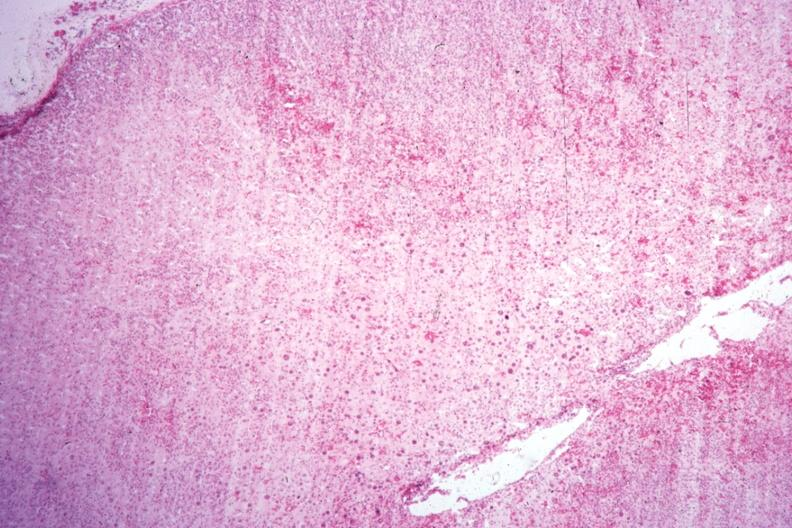s parathyroid present?
Answer the question using a single word or phrase. No 